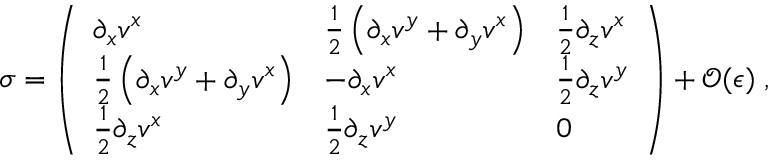Convert formula to latex. <formula><loc_0><loc_0><loc_500><loc_500>\sigma = \left ( \begin{array} { l l l } { \partial _ { x } { v ^ { x } } } & { \frac { 1 } { 2 } \left ( \partial _ { x } { v ^ { y } } + \partial _ { y } { v ^ { x } } \right ) } & { \frac { 1 } { 2 } \partial _ { z } { v ^ { x } } } \\ { \frac { 1 } { 2 } \left ( \partial _ { x } { v ^ { y } } + \partial _ { y } { v ^ { x } } \right ) } & { - \partial _ { x } { v ^ { x } } } & { \frac { 1 } { 2 } \partial _ { z } { v ^ { y } } } \\ { \frac { 1 } { 2 } \partial _ { z } { v ^ { x } } } & { \frac { 1 } { 2 } \partial _ { z } { v ^ { y } } } & { 0 } \end{array} \right ) + { \mathcal { O } } ( { \epsilon } ) \, ,</formula> 